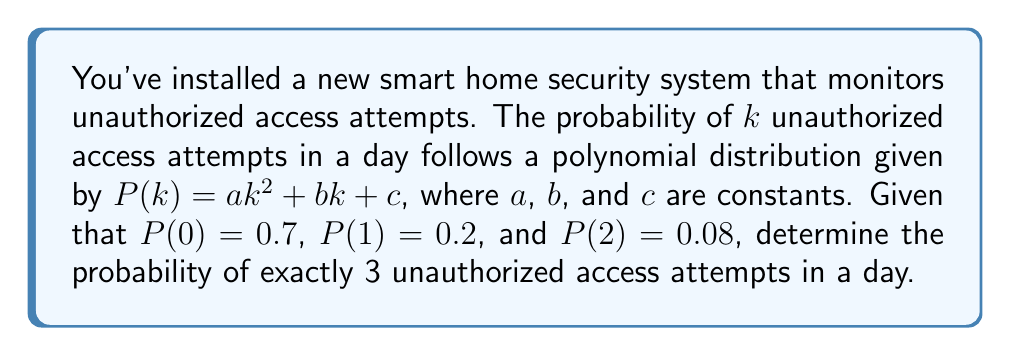Can you solve this math problem? To solve this problem, we need to follow these steps:

1) First, we need to find the values of $a$, $b$, and $c$ using the given information:

   $P(0) = a(0)^2 + b(0) + c = 0.7$, so $c = 0.7$
   $P(1) = a(1)^2 + b(1) + c = 0.2$, so $a + b + 0.7 = 0.2$
   $P(2) = a(2)^2 + b(2) + c = 0.08$, so $4a + 2b + 0.7 = 0.08$

2) From the second equation: $a + b = -0.5$

3) Substituting this into the third equation:
   $4a + 2(-0.5-a) + 0.7 = 0.08$
   $4a - 1 - 2a + 0.7 = 0.08$
   $2a - 0.3 = 0.08$
   $2a = 0.38$
   $a = 0.19$

4) Now we can find $b$:
   $a + b = -0.5$
   $0.19 + b = -0.5$
   $b = -0.69$

5) We have now determined that $P(k) = 0.19k^2 - 0.69k + 0.7$

6) To find $P(3)$, we simply substitute $k = 3$ into this equation:

   $P(3) = 0.19(3)^2 - 0.69(3) + 0.7$
         $= 0.19(9) - 2.07 + 0.7$
         $= 1.71 - 2.07 + 0.7$
         $= 0.34$

Therefore, the probability of exactly 3 unauthorized access attempts in a day is 0.34 or 34%.
Answer: 0.34 